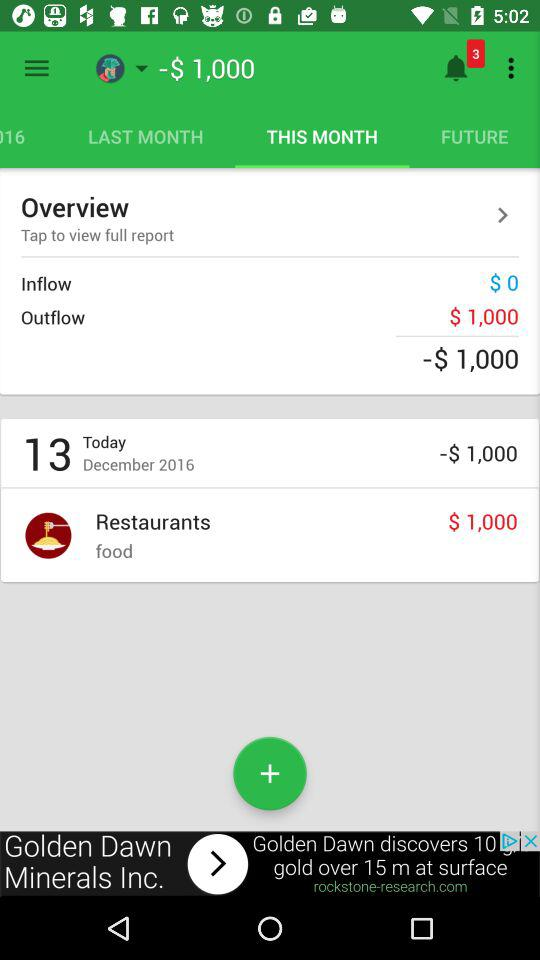What is the total amount of money spent on food?
Answer the question using a single word or phrase. $1,000 